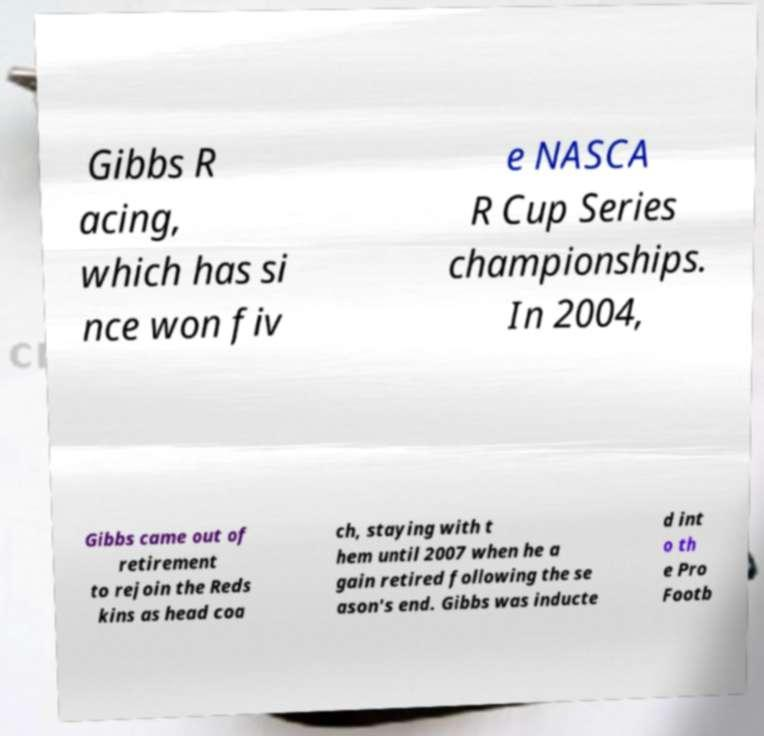Can you read and provide the text displayed in the image?This photo seems to have some interesting text. Can you extract and type it out for me? Gibbs R acing, which has si nce won fiv e NASCA R Cup Series championships. In 2004, Gibbs came out of retirement to rejoin the Reds kins as head coa ch, staying with t hem until 2007 when he a gain retired following the se ason's end. Gibbs was inducte d int o th e Pro Footb 